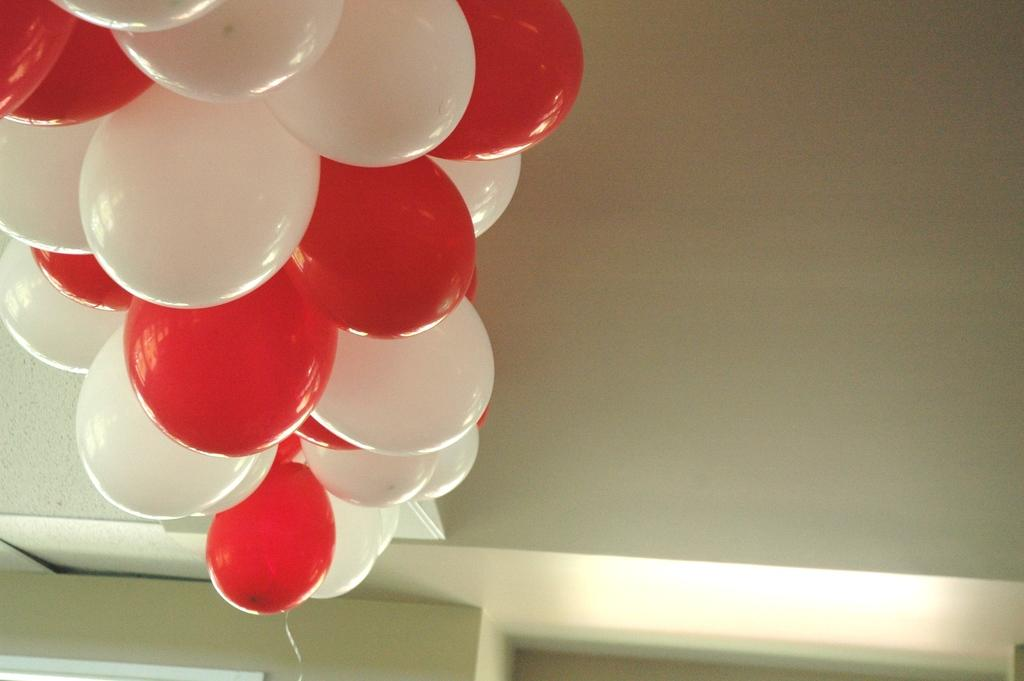What colors are the balloons on the wall in the image? The balloons on the wall are red and white colored. Where are the balloons located in the image? The balloons are on the wall in the image. What can be seen at the bottom of the wall in the image? There is a light at the bottom of the wall in the image. What type of club is being used to hit the balloons in the image? There is no club or ball being hit in the image; it only features balloons on the wall and a light at the bottom of the wall. 